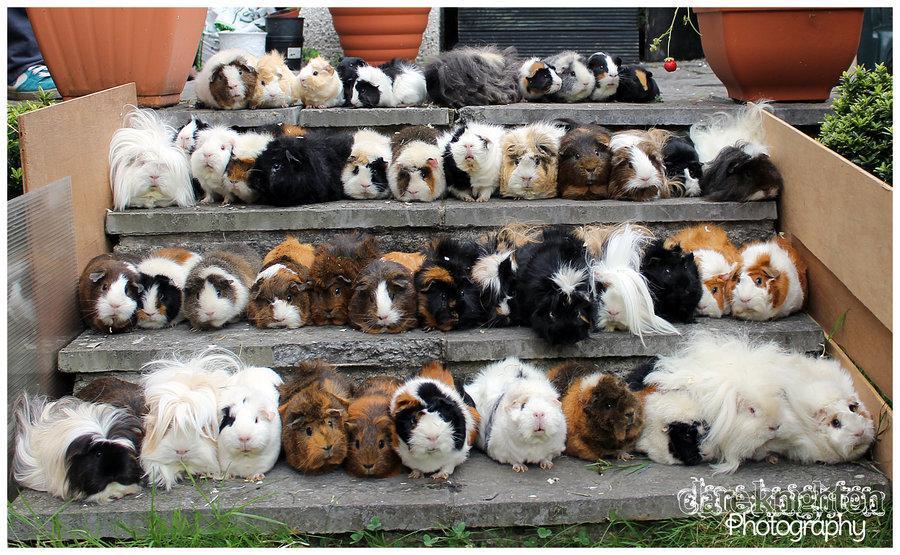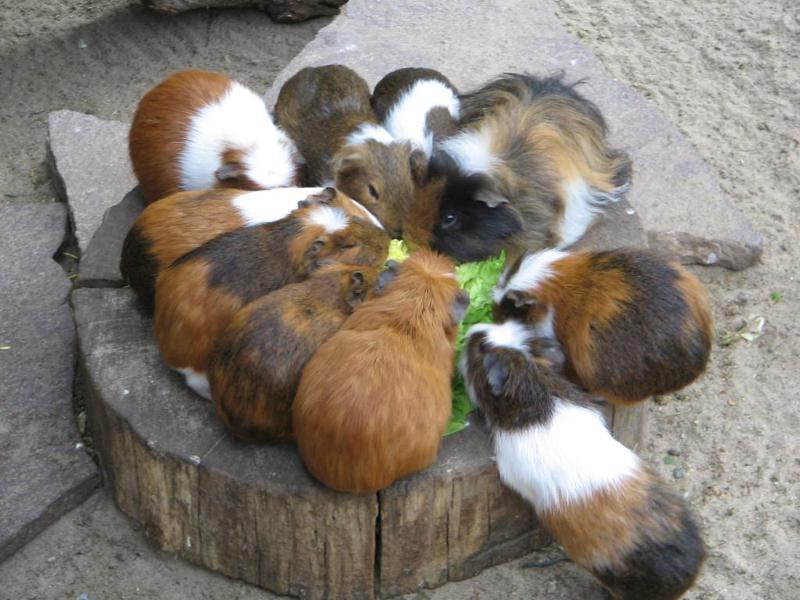The first image is the image on the left, the second image is the image on the right. Considering the images on both sides, is "An image shows variously colored hamsters arranged in stepped rows." valid? Answer yes or no. Yes. The first image is the image on the left, the second image is the image on the right. Assess this claim about the two images: "Some of the animals are sitting on steps outside.". Correct or not? Answer yes or no. Yes. 